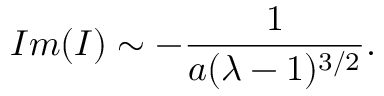<formula> <loc_0><loc_0><loc_500><loc_500>I m ( I ) \sim - { \frac { 1 } { a ( \lambda - 1 ) ^ { 3 / 2 } } } .</formula> 